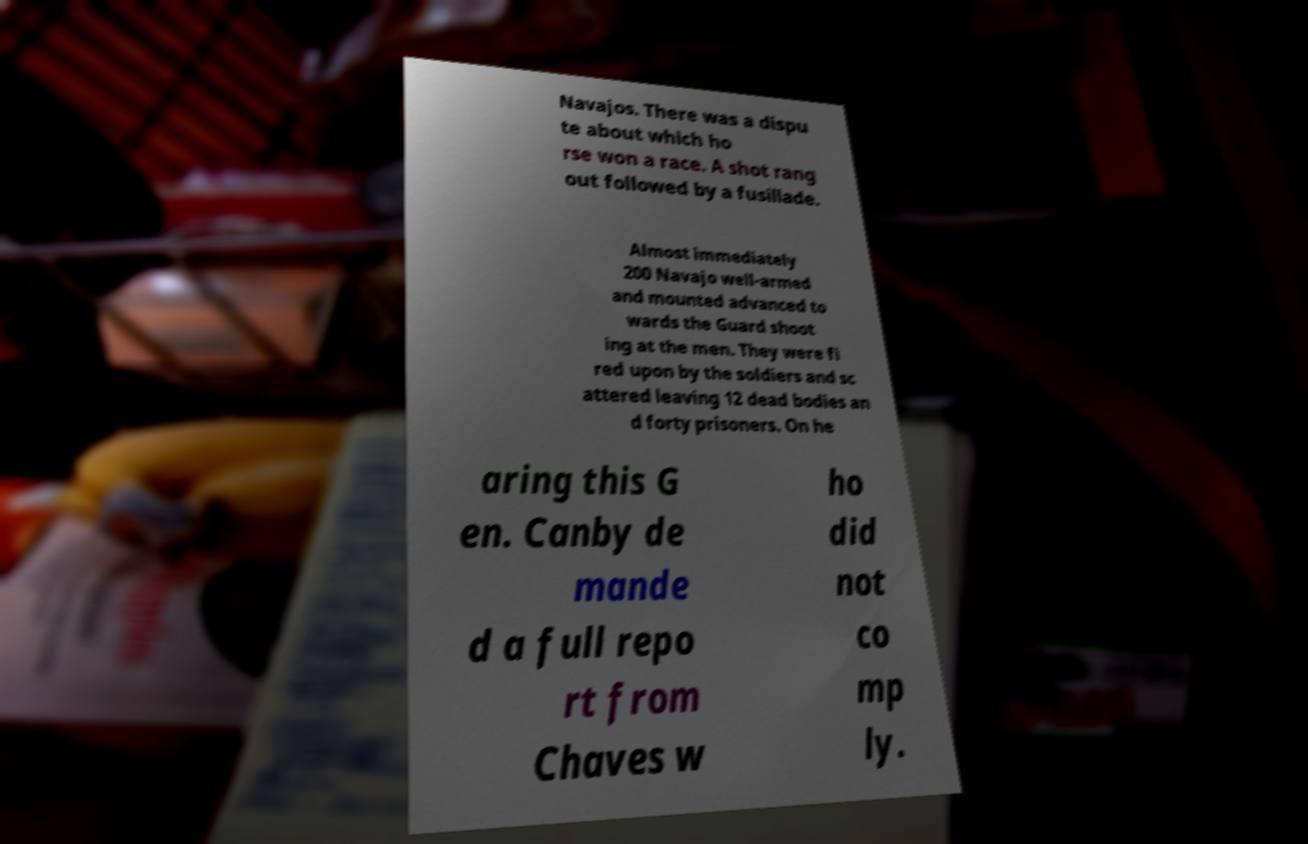Can you accurately transcribe the text from the provided image for me? Navajos. There was a dispu te about which ho rse won a race. A shot rang out followed by a fusillade. Almost immediately 200 Navajo well-armed and mounted advanced to wards the Guard shoot ing at the men. They were fi red upon by the soldiers and sc attered leaving 12 dead bodies an d forty prisoners. On he aring this G en. Canby de mande d a full repo rt from Chaves w ho did not co mp ly. 